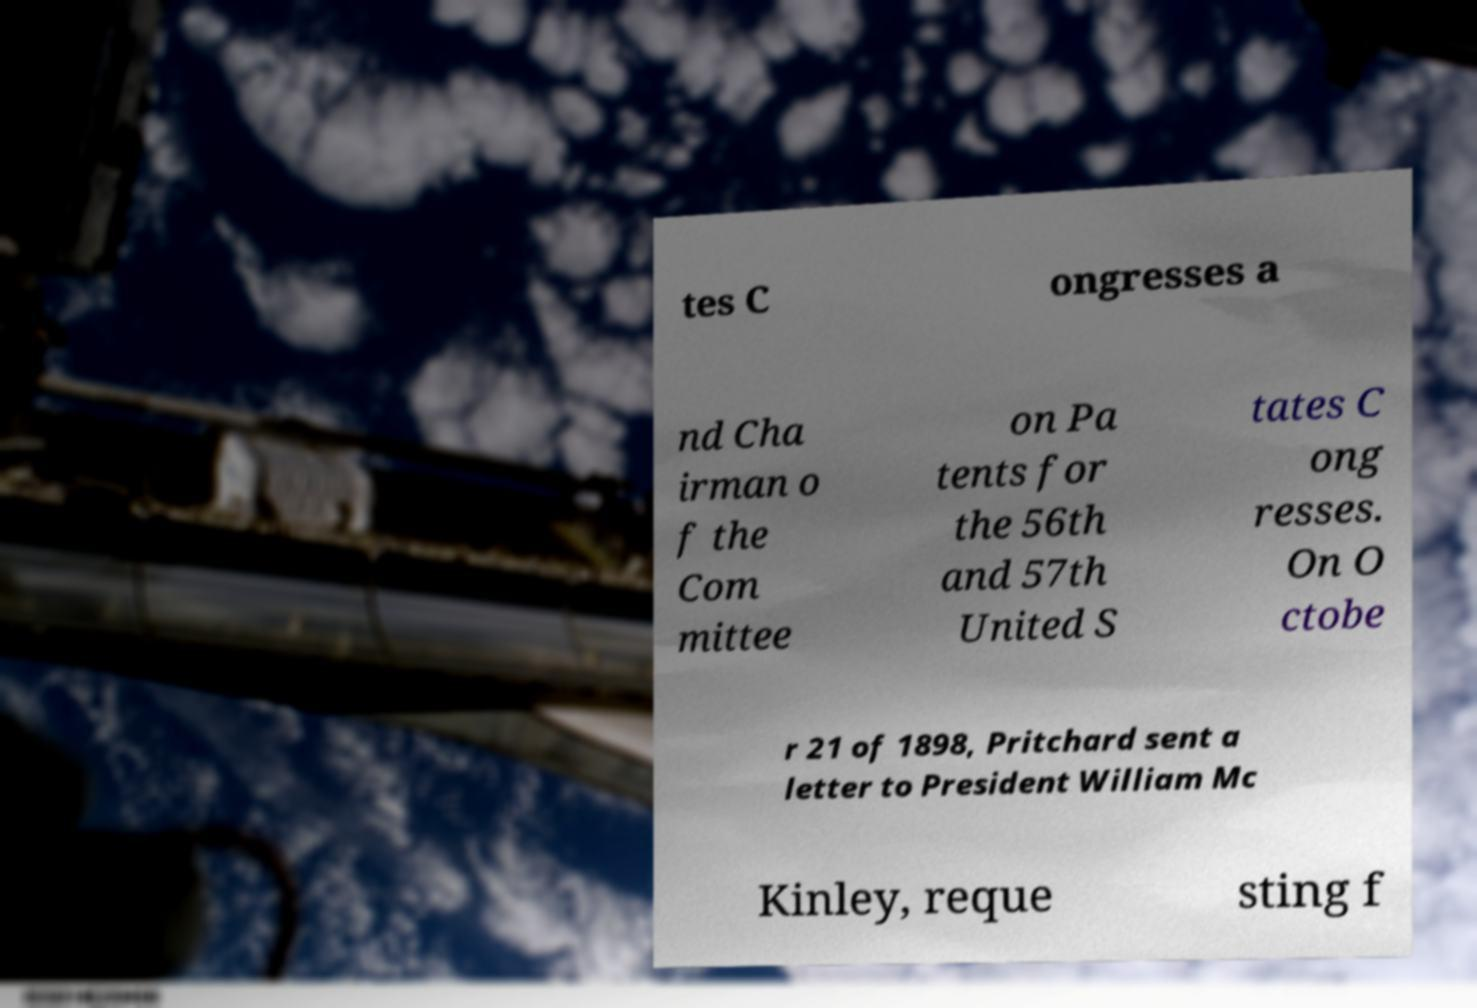Could you extract and type out the text from this image? tes C ongresses a nd Cha irman o f the Com mittee on Pa tents for the 56th and 57th United S tates C ong resses. On O ctobe r 21 of 1898, Pritchard sent a letter to President William Mc Kinley, reque sting f 